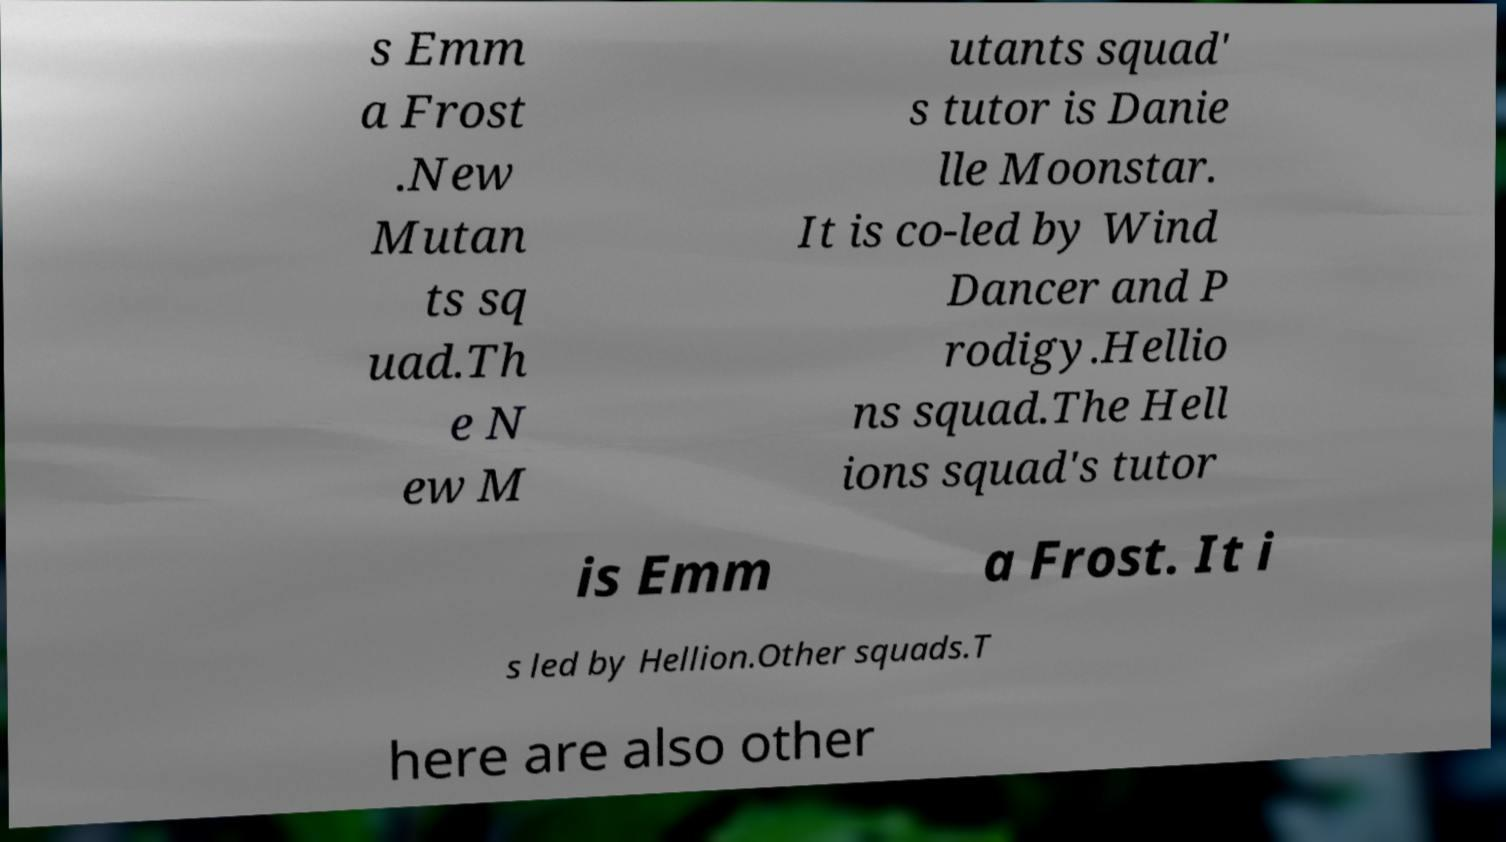For documentation purposes, I need the text within this image transcribed. Could you provide that? s Emm a Frost .New Mutan ts sq uad.Th e N ew M utants squad' s tutor is Danie lle Moonstar. It is co-led by Wind Dancer and P rodigy.Hellio ns squad.The Hell ions squad's tutor is Emm a Frost. It i s led by Hellion.Other squads.T here are also other 